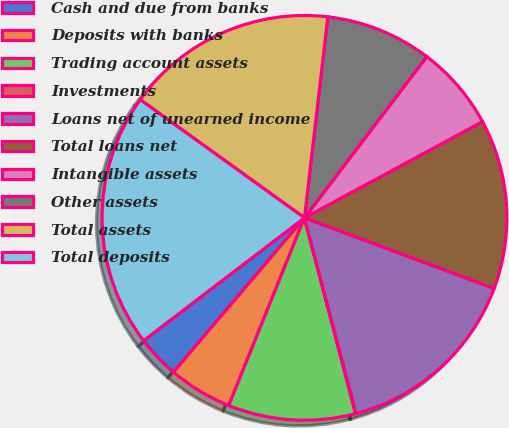Convert chart. <chart><loc_0><loc_0><loc_500><loc_500><pie_chart><fcel>Cash and due from banks<fcel>Deposits with banks<fcel>Trading account assets<fcel>Investments<fcel>Loans net of unearned income<fcel>Total loans net<fcel>Intangible assets<fcel>Other assets<fcel>Total assets<fcel>Total deposits<nl><fcel>3.42%<fcel>5.1%<fcel>10.17%<fcel>0.04%<fcel>15.23%<fcel>13.55%<fcel>6.79%<fcel>8.48%<fcel>16.92%<fcel>20.3%<nl></chart> 